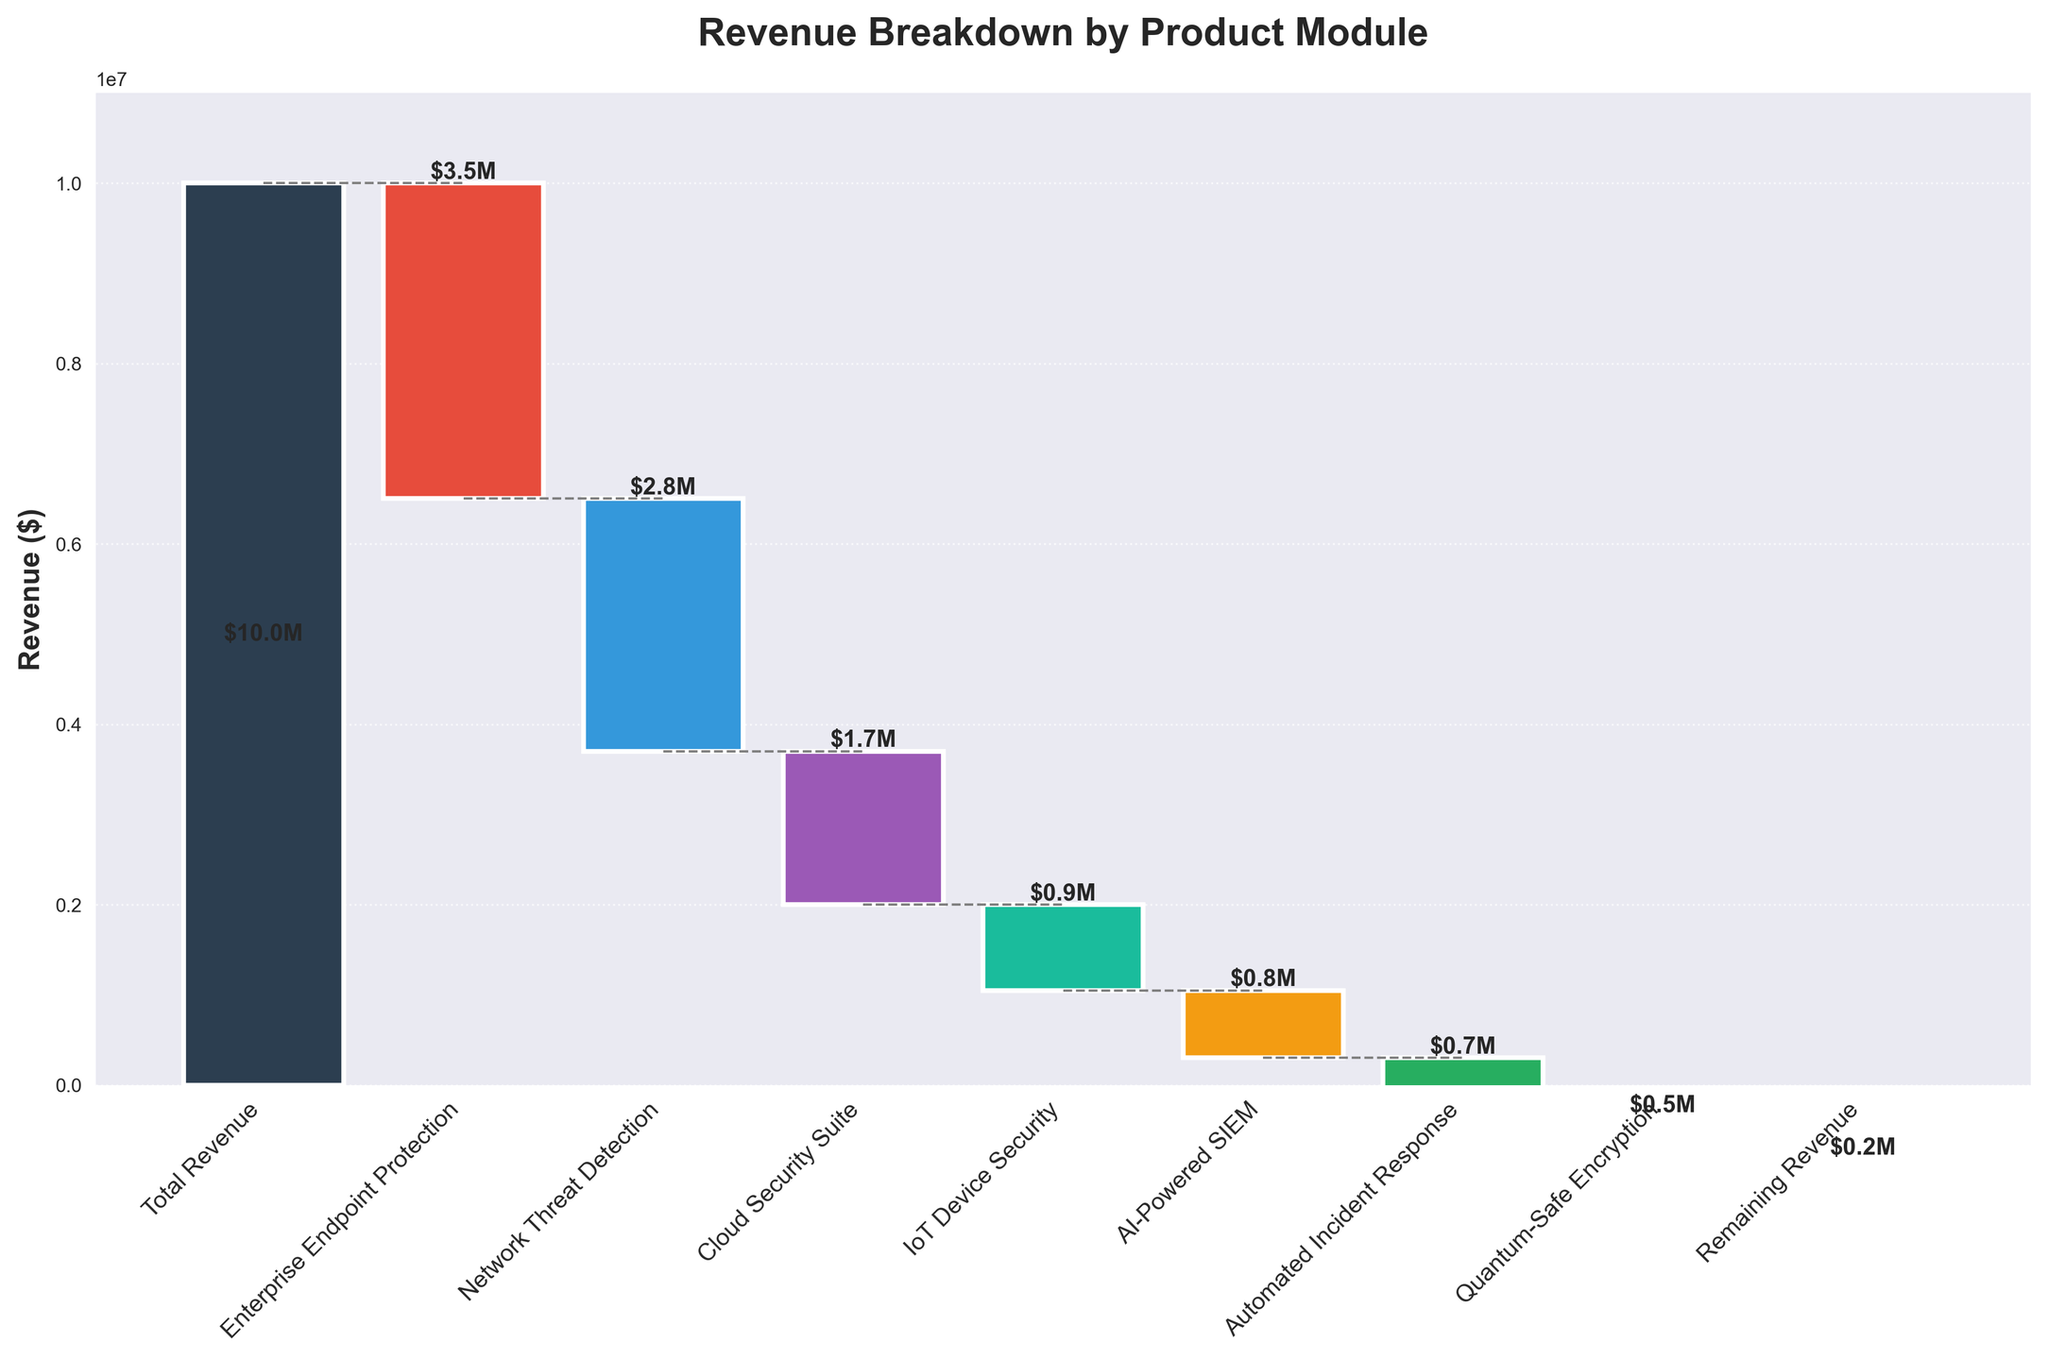What's the highest revenue among the product modules? The highest revenue is reflected by the total revenue bar. By examining the bars, the total revenue is $10 million.
Answer: $10 million Which product module contributes the most to the revenue loss? From the visual inspection of the bars, the "Enterprise Endpoint Protection" bar has the most significant downward movement indicating a revenue loss of $3.5 million.
Answer: Enterprise Endpoint Protection What's the overall remaining revenue after accounting for all the product modules? The remaining revenue is pointed out in the final bar, which is labeled "Remaining Revenue" and shows a value of $200,000.
Answer: $200,000 How does "Network Threat Detection" revenue compare with "Cloud Security Suite"? By examining the heights of the bars for both product modules, "Network Threat Detection" has a higher revenue loss of $2.8 million compared to "Cloud Security Suite" which has a revenue loss of $1.7 million.
Answer: "Network Threat Detection" has a greater revenue loss What's the difference in revenue loss between "IoT Device Security" and "AI-Powered SIEM"? The "IoT Device Security" module has a revenue loss of $950,000 and the "AI-Powered SIEM" module has a revenue loss of $750,000. The difference is calculated as $950,000 - $750,000 = $200,000.
Answer: $200,000 Which product module has the smallest revenue loss? By comparing the size of the downward bars, "Quantum-Safe Encryption" has the smallest revenue loss valued at $450,000.
Answer: Quantum-Safe Encryption What's the cumulative revenue after deducting the "Network Threat Detection" revenue? Starting with the total revenue of $10 million, we subtract the "Enterprise Endpoint Protection" ($3.5 million) to get $6.5 million, then deduct the "Network Threat Detection" ($2.8 million), resulting in $3.7 million.
Answer: $3.7 million How many product modules contribute to the revenue breakdown? By counting the individual labeled bars (excluding "Total Revenue" and "Remaining Revenue"), there are 7 product modules.
Answer: 7 What's the combined revenue loss of "AI-Powered SIEM" and "Automated Incident Response"? "AI-Powered SIEM" has a revenue loss of $750,000, and "Automated Incident Response" has a revenue loss of $650,000. Combined, it sums up to $750,000 + $650,000 = $1,400,000.
Answer: $1,400,000 What percentage of the total revenue is retained after all deductions? The remaining revenue is $200,000 out of the initial $10,000,000. To calculate the percentage: ($200,000 / $10,000,000) * 100 = 2%.
Answer: 2% 